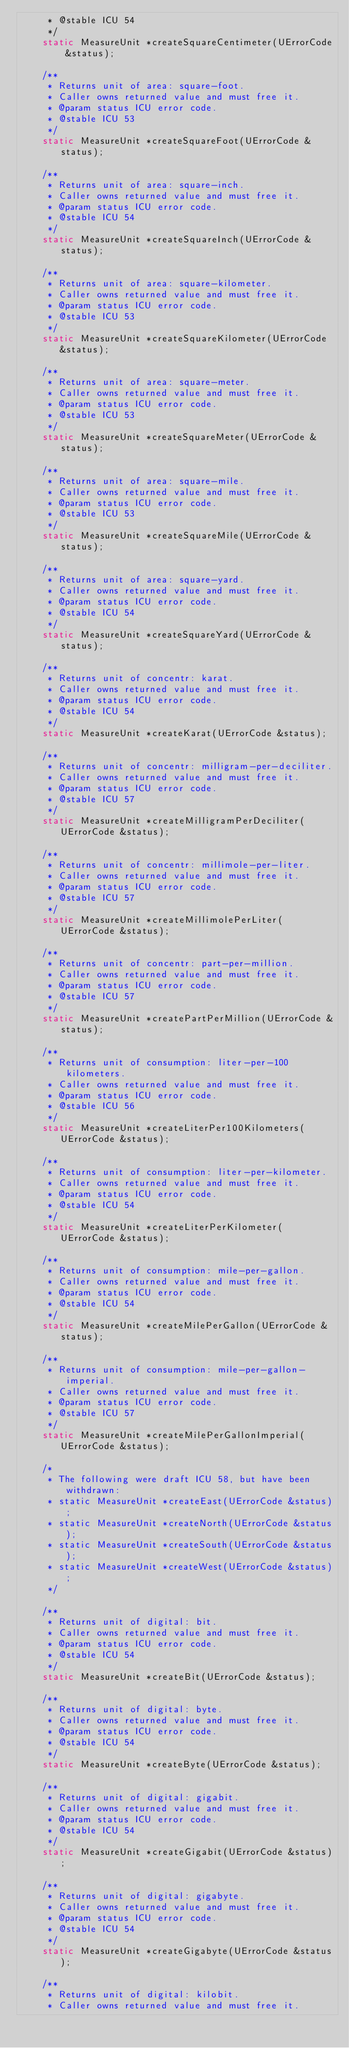Convert code to text. <code><loc_0><loc_0><loc_500><loc_500><_C_>     * @stable ICU 54
     */
    static MeasureUnit *createSquareCentimeter(UErrorCode &status);

    /**
     * Returns unit of area: square-foot.
     * Caller owns returned value and must free it.
     * @param status ICU error code.
     * @stable ICU 53
     */
    static MeasureUnit *createSquareFoot(UErrorCode &status);

    /**
     * Returns unit of area: square-inch.
     * Caller owns returned value and must free it.
     * @param status ICU error code.
     * @stable ICU 54
     */
    static MeasureUnit *createSquareInch(UErrorCode &status);

    /**
     * Returns unit of area: square-kilometer.
     * Caller owns returned value and must free it.
     * @param status ICU error code.
     * @stable ICU 53
     */
    static MeasureUnit *createSquareKilometer(UErrorCode &status);

    /**
     * Returns unit of area: square-meter.
     * Caller owns returned value and must free it.
     * @param status ICU error code.
     * @stable ICU 53
     */
    static MeasureUnit *createSquareMeter(UErrorCode &status);

    /**
     * Returns unit of area: square-mile.
     * Caller owns returned value and must free it.
     * @param status ICU error code.
     * @stable ICU 53
     */
    static MeasureUnit *createSquareMile(UErrorCode &status);

    /**
     * Returns unit of area: square-yard.
     * Caller owns returned value and must free it.
     * @param status ICU error code.
     * @stable ICU 54
     */
    static MeasureUnit *createSquareYard(UErrorCode &status);

    /**
     * Returns unit of concentr: karat.
     * Caller owns returned value and must free it.
     * @param status ICU error code.
     * @stable ICU 54
     */
    static MeasureUnit *createKarat(UErrorCode &status);

    /**
     * Returns unit of concentr: milligram-per-deciliter.
     * Caller owns returned value and must free it.
     * @param status ICU error code.
     * @stable ICU 57
     */
    static MeasureUnit *createMilligramPerDeciliter(UErrorCode &status);

    /**
     * Returns unit of concentr: millimole-per-liter.
     * Caller owns returned value and must free it.
     * @param status ICU error code.
     * @stable ICU 57
     */
    static MeasureUnit *createMillimolePerLiter(UErrorCode &status);

    /**
     * Returns unit of concentr: part-per-million.
     * Caller owns returned value and must free it.
     * @param status ICU error code.
     * @stable ICU 57
     */
    static MeasureUnit *createPartPerMillion(UErrorCode &status);

    /**
     * Returns unit of consumption: liter-per-100kilometers.
     * Caller owns returned value and must free it.
     * @param status ICU error code.
     * @stable ICU 56
     */
    static MeasureUnit *createLiterPer100Kilometers(UErrorCode &status);

    /**
     * Returns unit of consumption: liter-per-kilometer.
     * Caller owns returned value and must free it.
     * @param status ICU error code.
     * @stable ICU 54
     */
    static MeasureUnit *createLiterPerKilometer(UErrorCode &status);

    /**
     * Returns unit of consumption: mile-per-gallon.
     * Caller owns returned value and must free it.
     * @param status ICU error code.
     * @stable ICU 54
     */
    static MeasureUnit *createMilePerGallon(UErrorCode &status);

    /**
     * Returns unit of consumption: mile-per-gallon-imperial.
     * Caller owns returned value and must free it.
     * @param status ICU error code.
     * @stable ICU 57
     */
    static MeasureUnit *createMilePerGallonImperial(UErrorCode &status);

    /*
     * The following were draft ICU 58, but have been withdrawn:
     * static MeasureUnit *createEast(UErrorCode &status);
     * static MeasureUnit *createNorth(UErrorCode &status);
     * static MeasureUnit *createSouth(UErrorCode &status);
     * static MeasureUnit *createWest(UErrorCode &status);
     */

    /**
     * Returns unit of digital: bit.
     * Caller owns returned value and must free it.
     * @param status ICU error code.
     * @stable ICU 54
     */
    static MeasureUnit *createBit(UErrorCode &status);

    /**
     * Returns unit of digital: byte.
     * Caller owns returned value and must free it.
     * @param status ICU error code.
     * @stable ICU 54
     */
    static MeasureUnit *createByte(UErrorCode &status);

    /**
     * Returns unit of digital: gigabit.
     * Caller owns returned value and must free it.
     * @param status ICU error code.
     * @stable ICU 54
     */
    static MeasureUnit *createGigabit(UErrorCode &status);

    /**
     * Returns unit of digital: gigabyte.
     * Caller owns returned value and must free it.
     * @param status ICU error code.
     * @stable ICU 54
     */
    static MeasureUnit *createGigabyte(UErrorCode &status);

    /**
     * Returns unit of digital: kilobit.
     * Caller owns returned value and must free it.</code> 